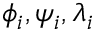Convert formula to latex. <formula><loc_0><loc_0><loc_500><loc_500>\phi _ { i } , \psi _ { i } , \lambda _ { i }</formula> 